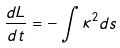<formula> <loc_0><loc_0><loc_500><loc_500>\frac { d L } { d t } = - \int \kappa ^ { 2 } d s</formula> 